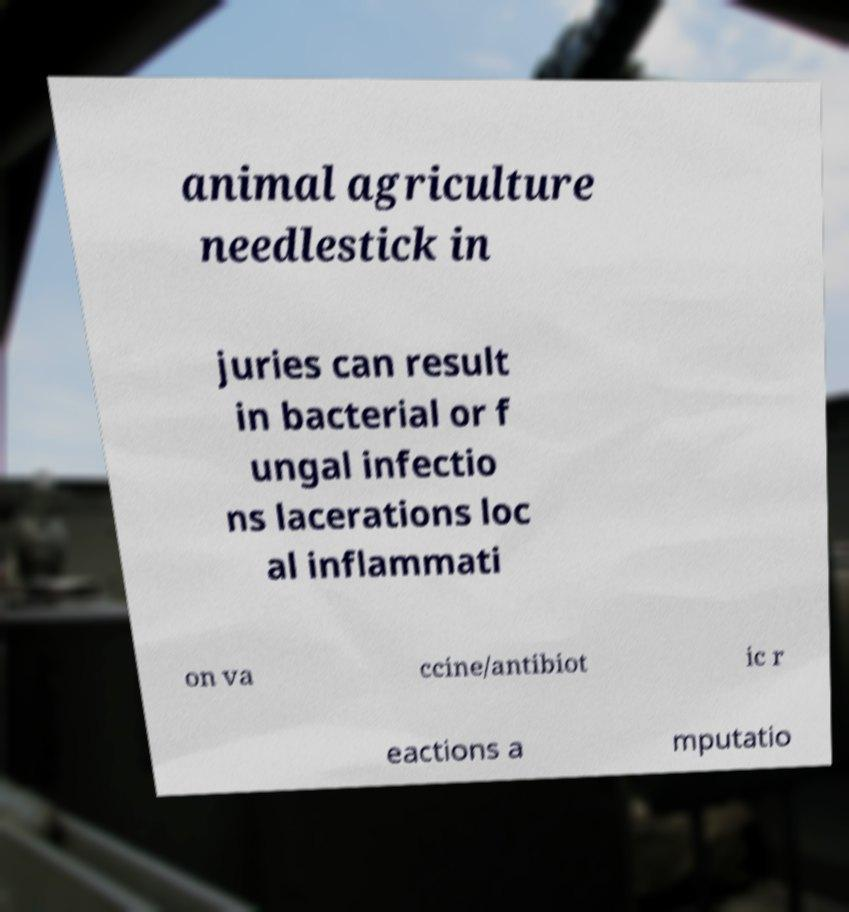There's text embedded in this image that I need extracted. Can you transcribe it verbatim? animal agriculture needlestick in juries can result in bacterial or f ungal infectio ns lacerations loc al inflammati on va ccine/antibiot ic r eactions a mputatio 